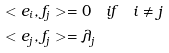Convert formula to latex. <formula><loc_0><loc_0><loc_500><loc_500>& < e _ { i } , f _ { j } > = 0 \quad i f \quad i \ne j \\ & < e _ { j } , f _ { j } > = \lambda _ { j }</formula> 